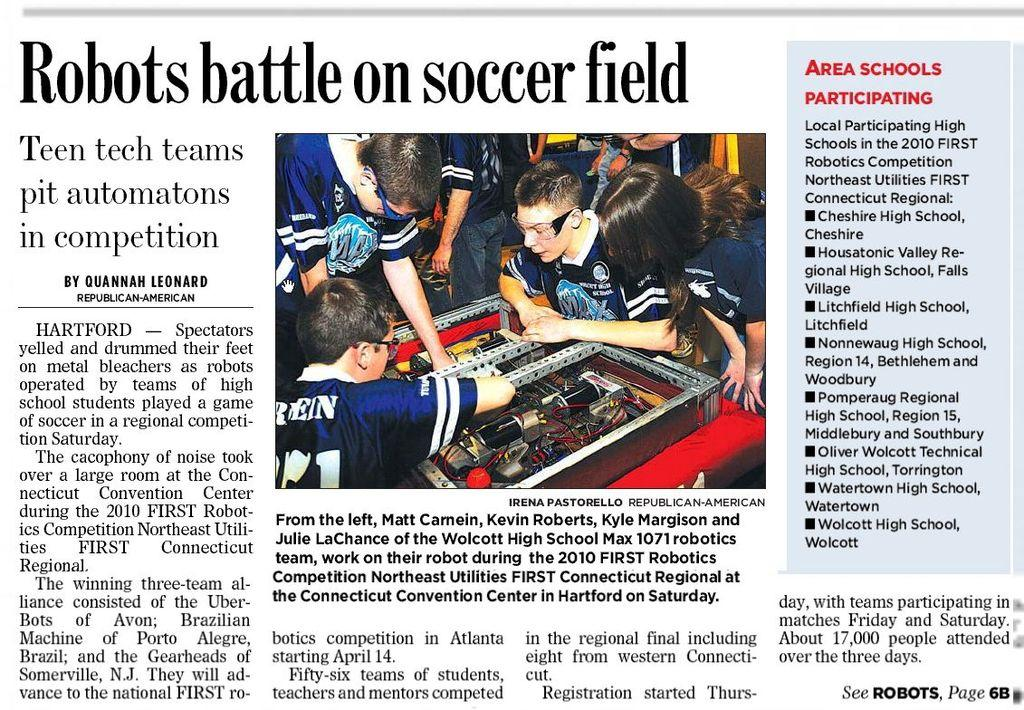What can be seen in the image involving multiple individuals? There is a group of people in the image. What else is present in the image besides the group of people? There are objects in the image. Can you describe the text that is visible in the image? There is text on a page in the image. What type of copper material can be seen in the image? There is no copper material present in the image. How does the image promote health and wellness? The image does not specifically promote health and wellness; it simply contains a group of people, objects, and text on a page. 